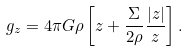<formula> <loc_0><loc_0><loc_500><loc_500>g _ { z } = 4 \pi G \rho \left [ z + \frac { \Sigma } { 2 \rho } \frac { | z | } { z } \right ] .</formula> 